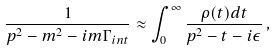Convert formula to latex. <formula><loc_0><loc_0><loc_500><loc_500>\frac { 1 } { p ^ { 2 } - m ^ { 2 } - i m \Gamma _ { i n t } } \approx \int _ { 0 } ^ { \infty } \frac { \rho ( t ) d t } { p ^ { 2 } - t - i \epsilon } \, ,</formula> 